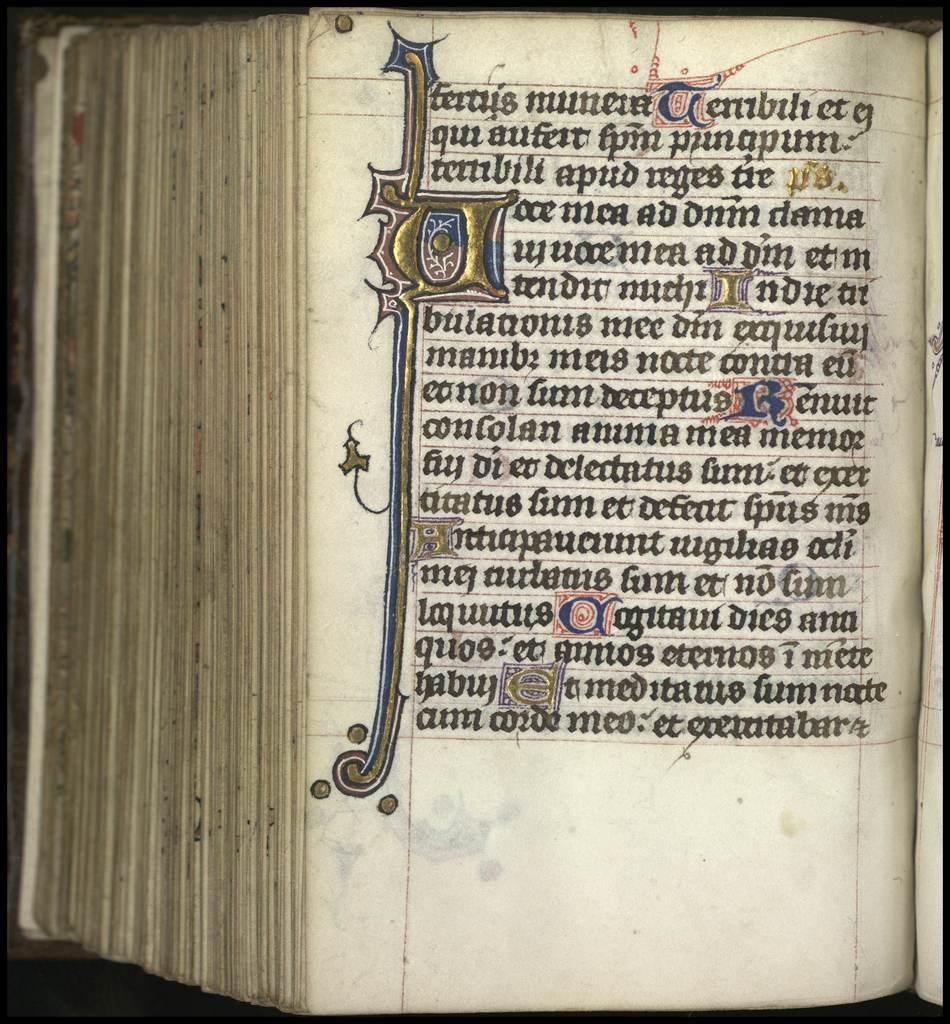Is this book written in english?
Provide a short and direct response. No. 